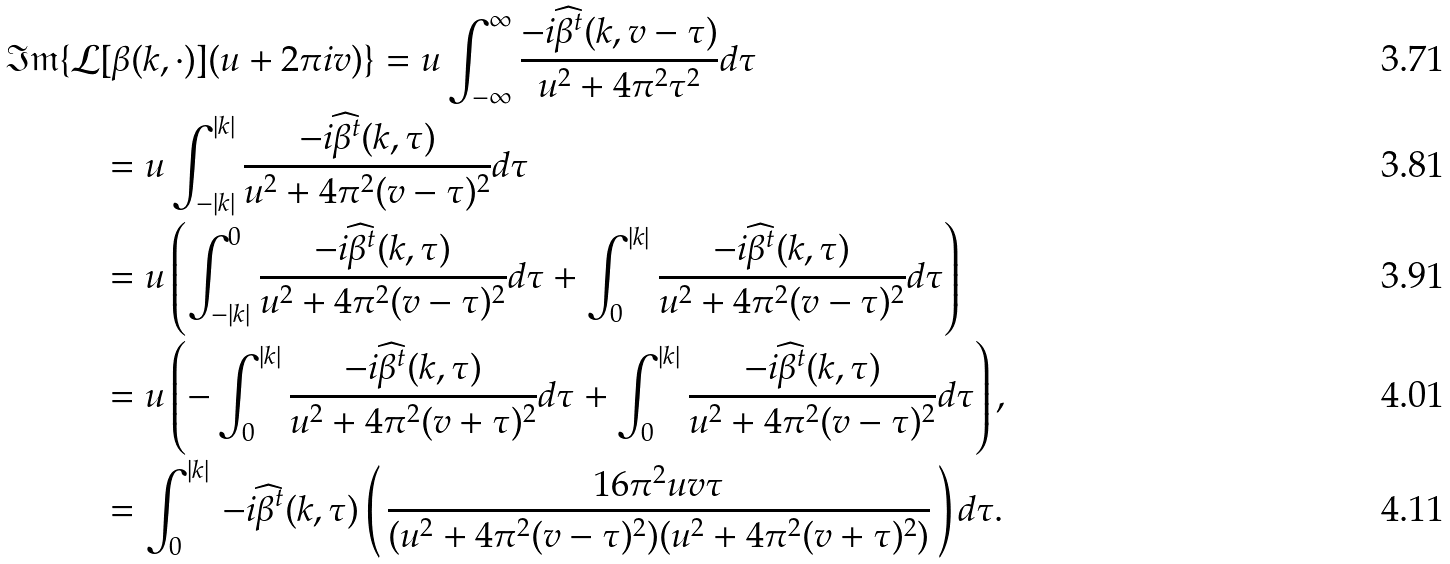<formula> <loc_0><loc_0><loc_500><loc_500>\mathfrak { I m } \{ \mathcal { L } & [ \beta ( k , \cdot ) ] ( u + 2 \pi i v ) \} = u \int _ { - \infty } ^ { \infty } \frac { - i \widehat { \beta } ^ { t } ( k , v - \tau ) } { u ^ { 2 } + 4 \pi ^ { 2 } \tau ^ { 2 } } d \tau \\ & = u \int _ { - | k | } ^ { | k | } \frac { - i \widehat { \beta } ^ { t } ( k , \tau ) } { u ^ { 2 } + 4 \pi ^ { 2 } ( v - \tau ) ^ { 2 } } d \tau \\ & = u \left ( \int _ { - | k | } ^ { 0 } \frac { - i \widehat { \beta } ^ { t } ( k , \tau ) } { u ^ { 2 } + 4 \pi ^ { 2 } ( v - \tau ) ^ { 2 } } d \tau + \int _ { 0 } ^ { | k | } \frac { - i \widehat { \beta } ^ { t } ( k , \tau ) } { u ^ { 2 } + 4 \pi ^ { 2 } ( v - \tau ) ^ { 2 } } d \tau \right ) \\ & = u \left ( - \int _ { 0 } ^ { | k | } \frac { - i \widehat { \beta } ^ { t } ( k , \tau ) } { u ^ { 2 } + 4 \pi ^ { 2 } ( v + \tau ) ^ { 2 } } d \tau + \int _ { 0 } ^ { | k | } \frac { - i \widehat { \beta } ^ { t } ( k , \tau ) } { u ^ { 2 } + 4 \pi ^ { 2 } ( v - \tau ) ^ { 2 } } d \tau \right ) , \\ & = \int _ { 0 } ^ { | k | } \, - i \widehat { \beta } ^ { t } ( k , \tau ) \left ( \, \frac { 1 6 \pi ^ { 2 } u v \tau } { ( u ^ { 2 } + 4 \pi ^ { 2 } ( v - \tau ) ^ { 2 } ) ( u ^ { 2 } + 4 \pi ^ { 2 } ( v + \tau ) ^ { 2 } ) } \, \right ) d \tau .</formula> 